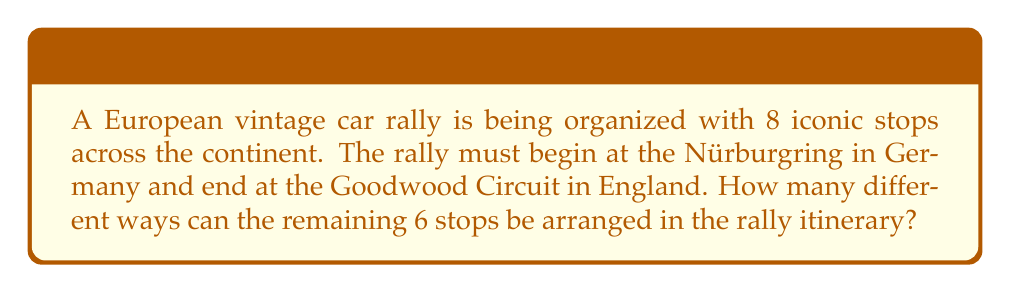Solve this math problem. Let's approach this step-by-step:

1) We have 8 total stops, but the first (Nürburgring) and last (Goodwood Circuit) are fixed.

2) This means we need to arrange the remaining 6 stops.

3) This is a classic permutation problem. We are arranging all 6 remaining stops, and the order matters.

4) The formula for permutations is:

   $$P(n) = n!$$

   Where $n$ is the number of items to be arranged.

5) In this case, $n = 6$, so we need to calculate:

   $$P(6) = 6!$$

6) Let's expand this:

   $$6! = 6 \times 5 \times 4 \times 3 \times 2 \times 1 = 720$$

Therefore, there are 720 different ways to arrange the 6 stops between the fixed start and end points of the rally.
Answer: 720 